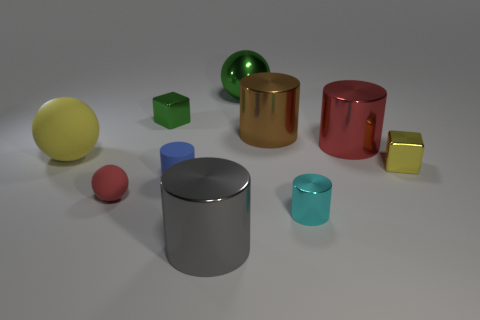Subtract all red cylinders. How many cylinders are left? 4 Subtract all small cyan shiny cylinders. How many cylinders are left? 4 Subtract all purple cylinders. Subtract all red blocks. How many cylinders are left? 5 Subtract all cubes. How many objects are left? 8 Subtract 0 red blocks. How many objects are left? 10 Subtract all metal cubes. Subtract all blue rubber cylinders. How many objects are left? 7 Add 8 rubber cylinders. How many rubber cylinders are left? 9 Add 9 large gray things. How many large gray things exist? 10 